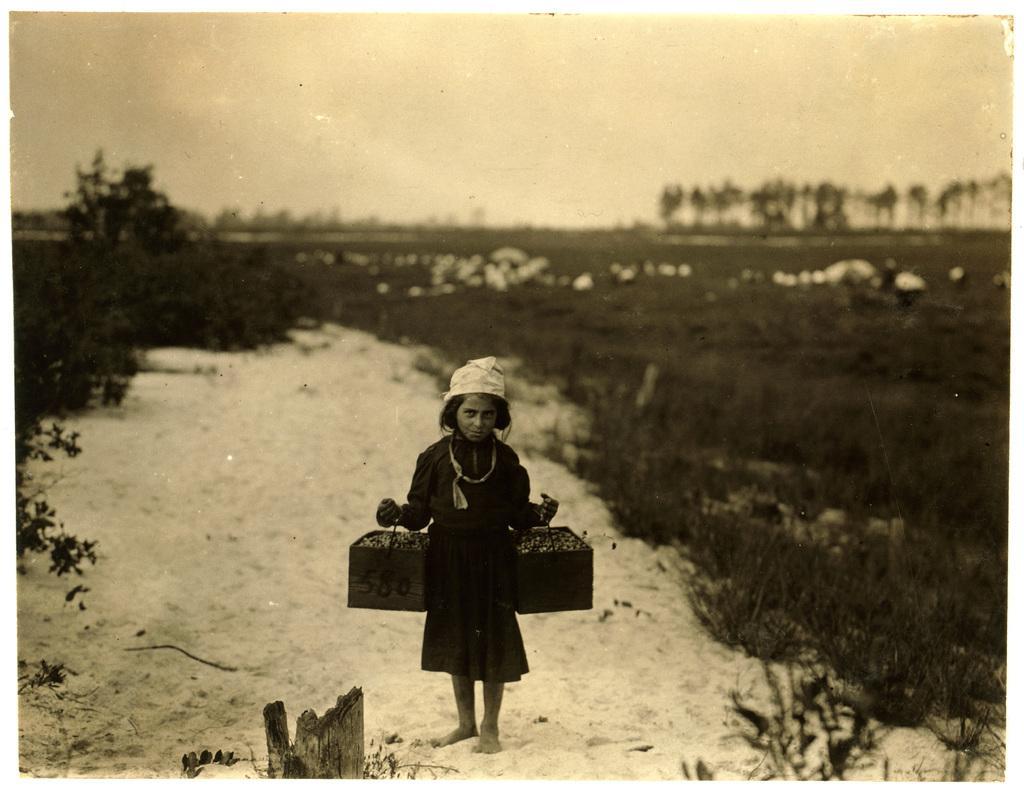Describe this image in one or two sentences. In this picture we can see a girl holding 2 baskets in her hands and standing on the snowy ground surrounded by trees and plants. 